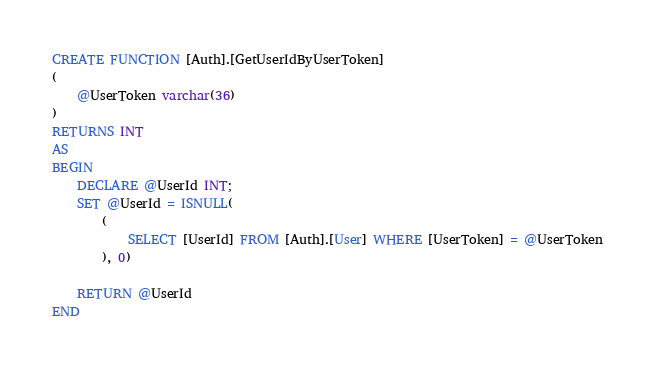Convert code to text. <code><loc_0><loc_0><loc_500><loc_500><_SQL_>CREATE FUNCTION [Auth].[GetUserIdByUserToken]
(
	@UserToken varchar(36)
)
RETURNS INT
AS
BEGIN
	DECLARE @UserId INT;
	SET @UserId = ISNULL(
		(
			SELECT [UserId] FROM [Auth].[User] WHERE [UserToken] = @UserToken 
		), 0)

	RETURN @UserId
END</code> 